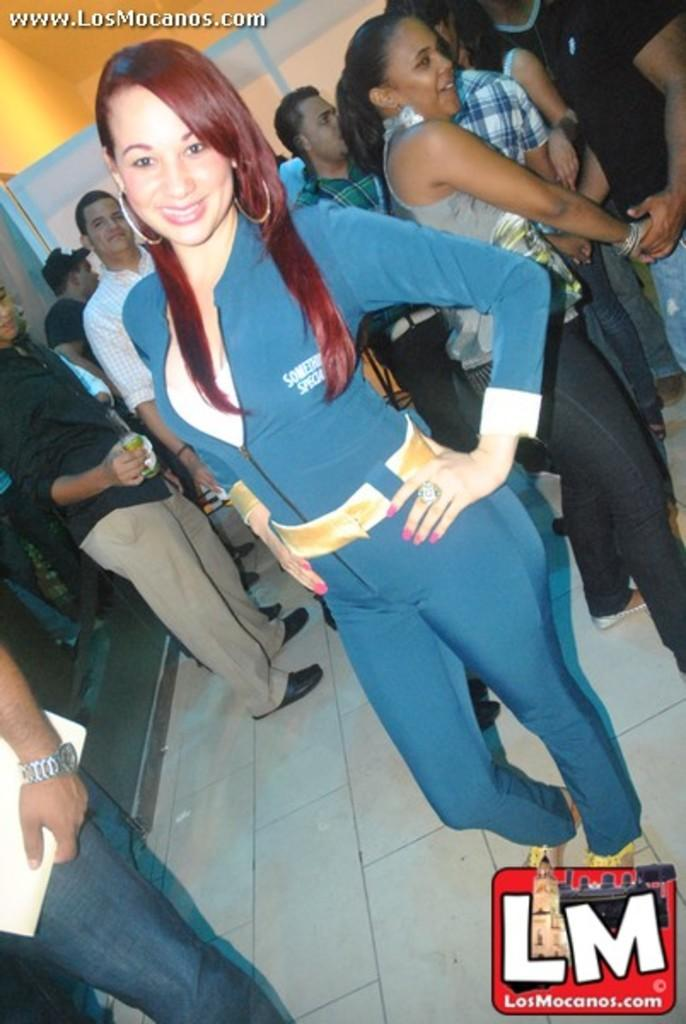What is happening with the people in the image? The people in the image are standing and smiling. What are the people wearing in the image? The people are wearing clothes, and some of them are wearing shoes. How many watermarks are present in the image? There are two watermarks in the image, one in the bottom right corner and one in the top left corner. What type of nest can be seen in the image? There is no nest present in the image; it features people standing and smiling. 